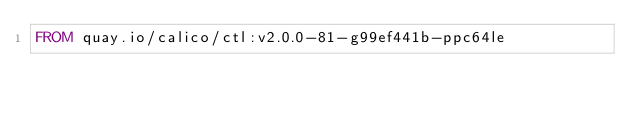Convert code to text. <code><loc_0><loc_0><loc_500><loc_500><_Dockerfile_>FROM quay.io/calico/ctl:v2.0.0-81-g99ef441b-ppc64le
</code> 